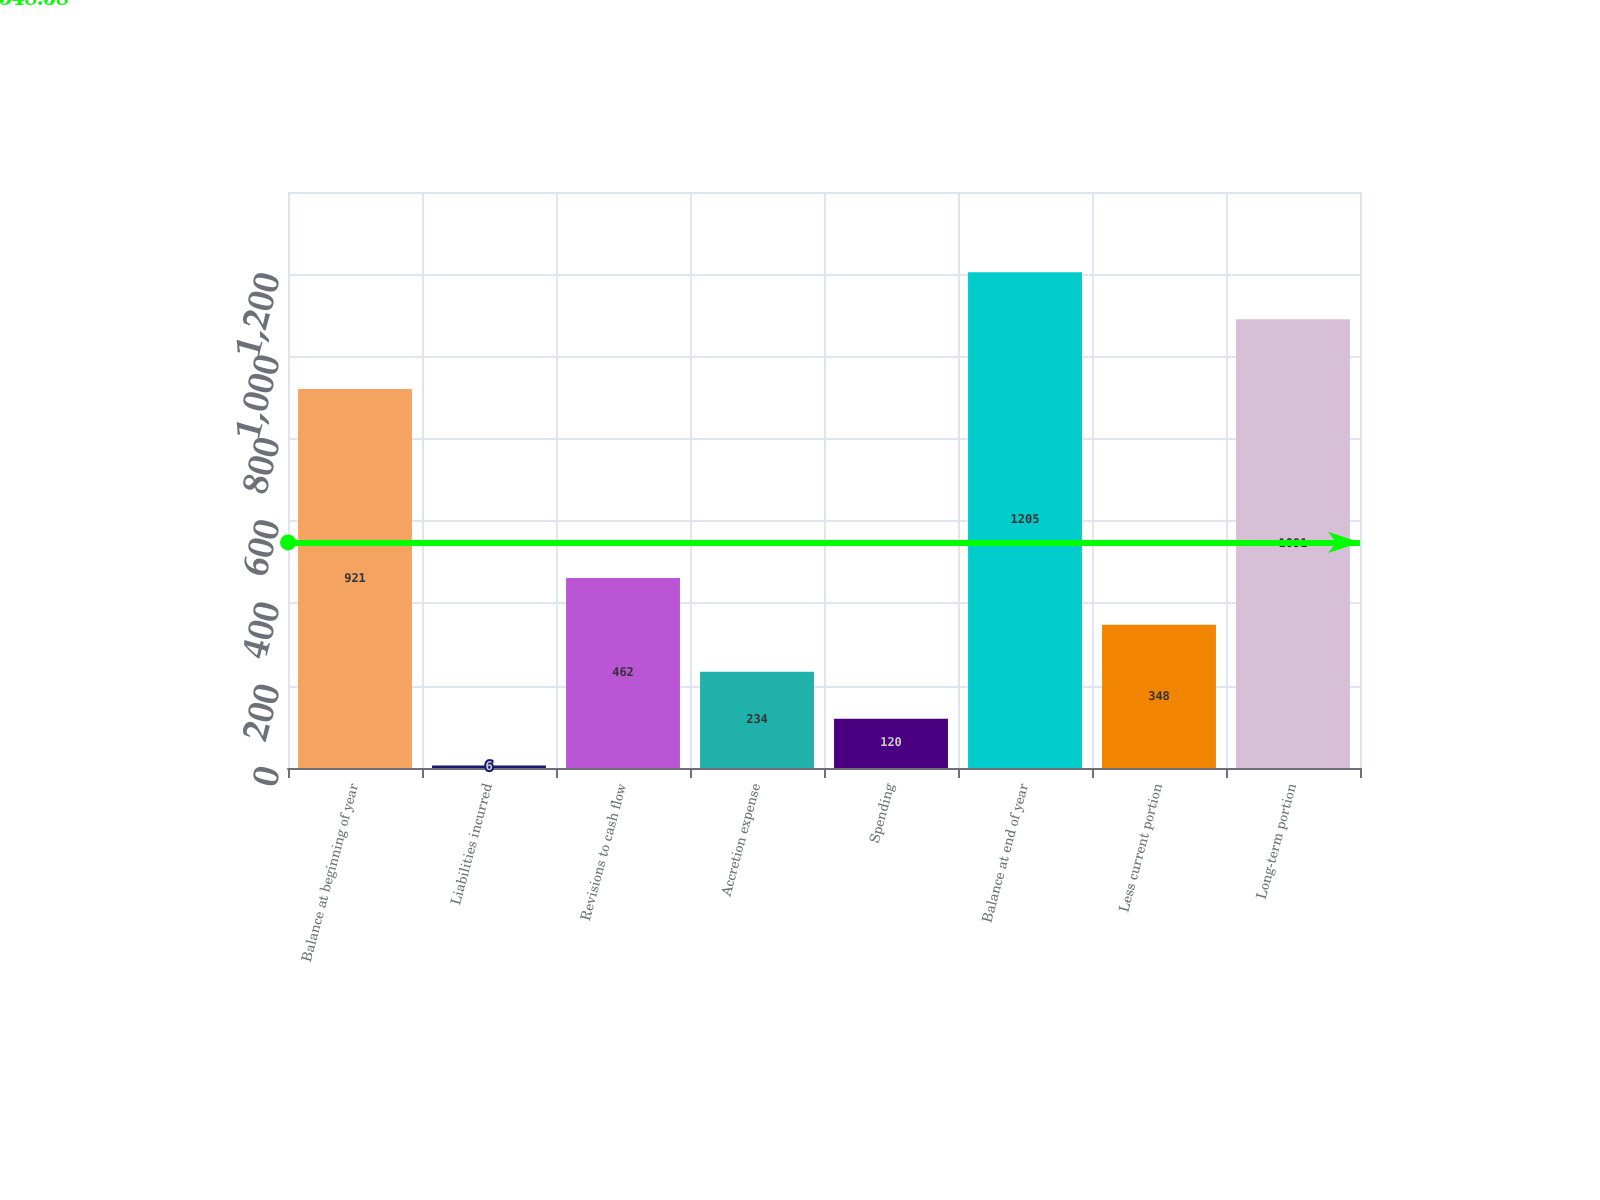Convert chart. <chart><loc_0><loc_0><loc_500><loc_500><bar_chart><fcel>Balance at beginning of year<fcel>Liabilities incurred<fcel>Revisions to cash flow<fcel>Accretion expense<fcel>Spending<fcel>Balance at end of year<fcel>Less current portion<fcel>Long-term portion<nl><fcel>921<fcel>6<fcel>462<fcel>234<fcel>120<fcel>1205<fcel>348<fcel>1091<nl></chart> 